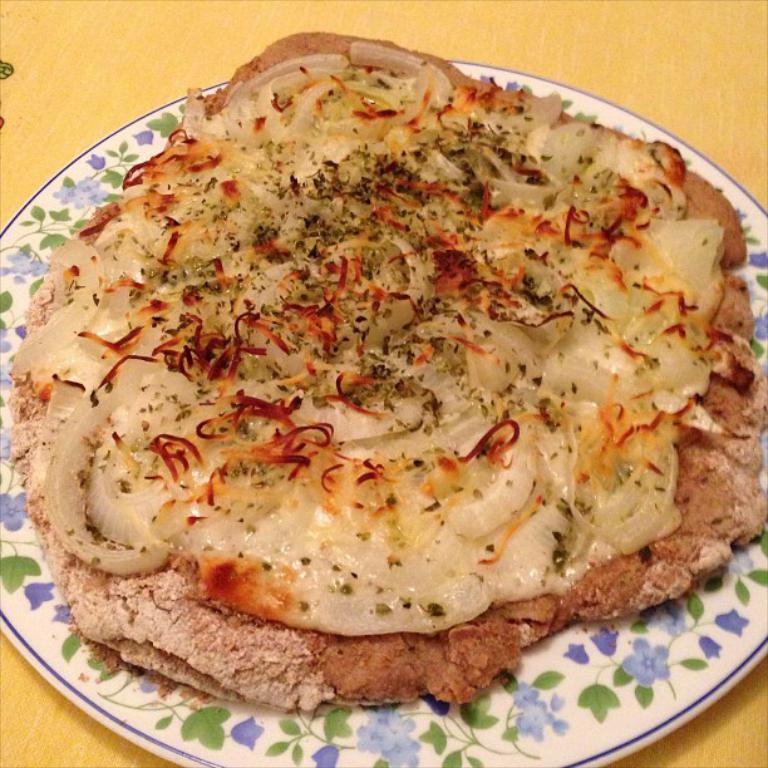What piece of furniture is present in the image? There is a table in the image. What is placed on the table? There is a plate containing food on the table. What type of baby clothing is visible in the image? There is no baby clothing present in the image; it only features a table with a plate containing food. 